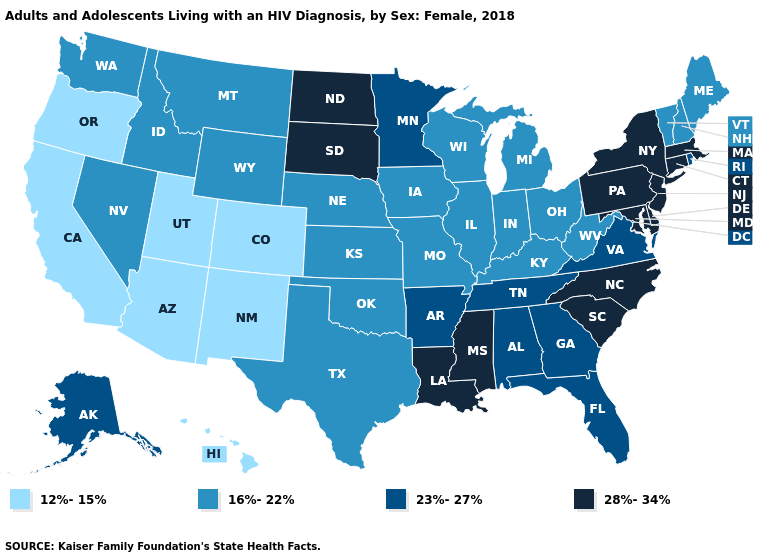What is the highest value in the USA?
Concise answer only. 28%-34%. Does Oklahoma have the same value as Texas?
Keep it brief. Yes. What is the lowest value in the South?
Be succinct. 16%-22%. Does New Mexico have the same value as Arizona?
Quick response, please. Yes. Does Connecticut have the same value as Missouri?
Quick response, please. No. Which states have the lowest value in the Northeast?
Give a very brief answer. Maine, New Hampshire, Vermont. Is the legend a continuous bar?
Give a very brief answer. No. What is the value of Kentucky?
Give a very brief answer. 16%-22%. Does California have a lower value than Wisconsin?
Concise answer only. Yes. Does Kansas have the lowest value in the USA?
Be succinct. No. Does the map have missing data?
Be succinct. No. What is the lowest value in states that border Alabama?
Write a very short answer. 23%-27%. Among the states that border Colorado , which have the highest value?
Write a very short answer. Kansas, Nebraska, Oklahoma, Wyoming. Name the states that have a value in the range 12%-15%?
Give a very brief answer. Arizona, California, Colorado, Hawaii, New Mexico, Oregon, Utah. What is the lowest value in the West?
Give a very brief answer. 12%-15%. 